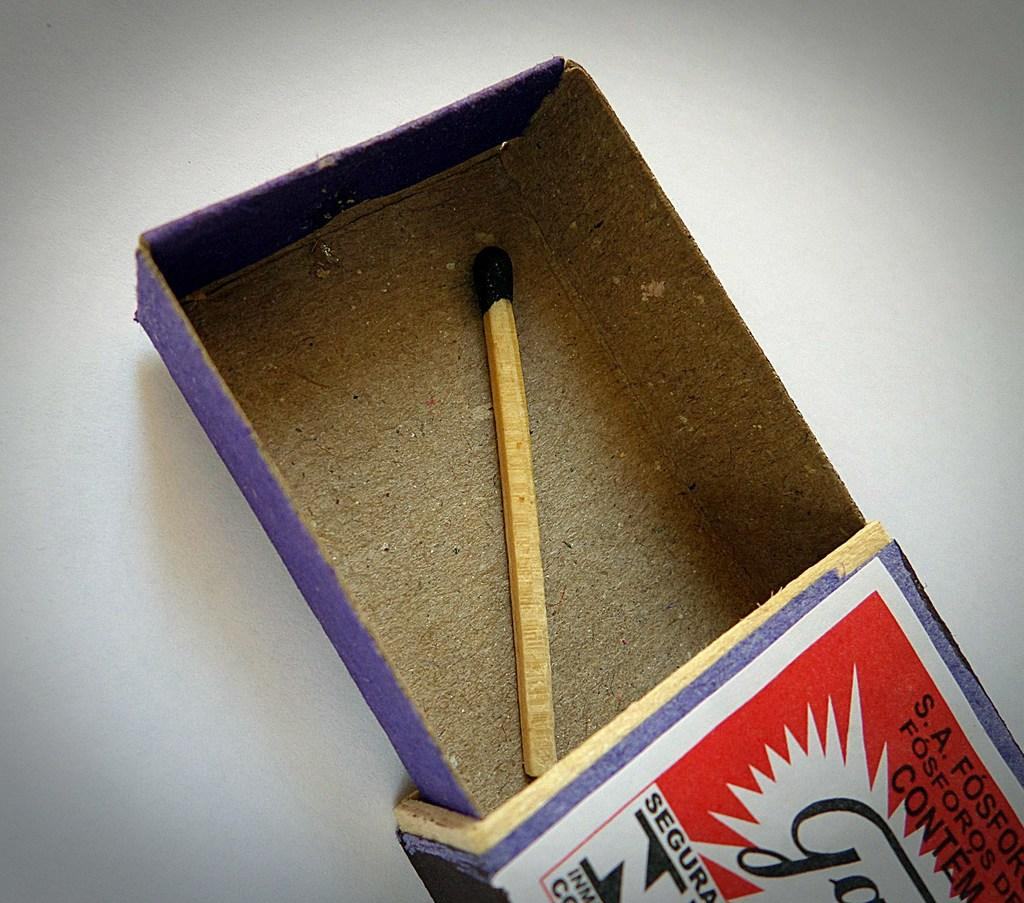Provide a one-sentence caption for the provided image. A box of matches containing only one last match has a label that starts with the S.A. 